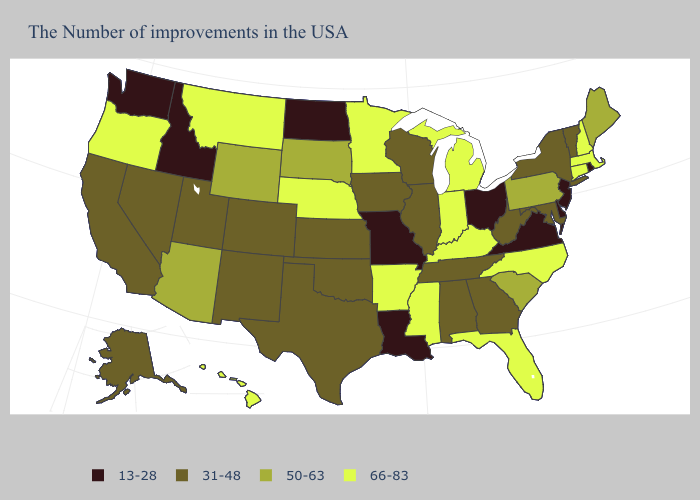Among the states that border Idaho , which have the highest value?
Concise answer only. Montana, Oregon. Which states have the lowest value in the USA?
Give a very brief answer. Rhode Island, New Jersey, Delaware, Virginia, Ohio, Louisiana, Missouri, North Dakota, Idaho, Washington. Does Virginia have the lowest value in the South?
Answer briefly. Yes. Name the states that have a value in the range 50-63?
Write a very short answer. Maine, Pennsylvania, South Carolina, South Dakota, Wyoming, Arizona. Name the states that have a value in the range 31-48?
Short answer required. Vermont, New York, Maryland, West Virginia, Georgia, Alabama, Tennessee, Wisconsin, Illinois, Iowa, Kansas, Oklahoma, Texas, Colorado, New Mexico, Utah, Nevada, California, Alaska. Name the states that have a value in the range 50-63?
Quick response, please. Maine, Pennsylvania, South Carolina, South Dakota, Wyoming, Arizona. Name the states that have a value in the range 66-83?
Keep it brief. Massachusetts, New Hampshire, Connecticut, North Carolina, Florida, Michigan, Kentucky, Indiana, Mississippi, Arkansas, Minnesota, Nebraska, Montana, Oregon, Hawaii. Name the states that have a value in the range 50-63?
Short answer required. Maine, Pennsylvania, South Carolina, South Dakota, Wyoming, Arizona. Among the states that border Massachusetts , does Vermont have the highest value?
Quick response, please. No. Among the states that border Michigan , does Indiana have the lowest value?
Be succinct. No. What is the highest value in states that border Indiana?
Be succinct. 66-83. Name the states that have a value in the range 31-48?
Be succinct. Vermont, New York, Maryland, West Virginia, Georgia, Alabama, Tennessee, Wisconsin, Illinois, Iowa, Kansas, Oklahoma, Texas, Colorado, New Mexico, Utah, Nevada, California, Alaska. Name the states that have a value in the range 31-48?
Quick response, please. Vermont, New York, Maryland, West Virginia, Georgia, Alabama, Tennessee, Wisconsin, Illinois, Iowa, Kansas, Oklahoma, Texas, Colorado, New Mexico, Utah, Nevada, California, Alaska. Among the states that border South Dakota , does Wyoming have the lowest value?
Give a very brief answer. No. Name the states that have a value in the range 50-63?
Answer briefly. Maine, Pennsylvania, South Carolina, South Dakota, Wyoming, Arizona. 